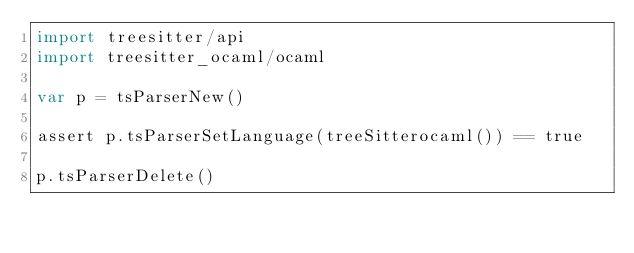Convert code to text. <code><loc_0><loc_0><loc_500><loc_500><_Nim_>import treesitter/api
import treesitter_ocaml/ocaml

var p = tsParserNew()

assert p.tsParserSetLanguage(treeSitterocaml()) == true

p.tsParserDelete()</code> 